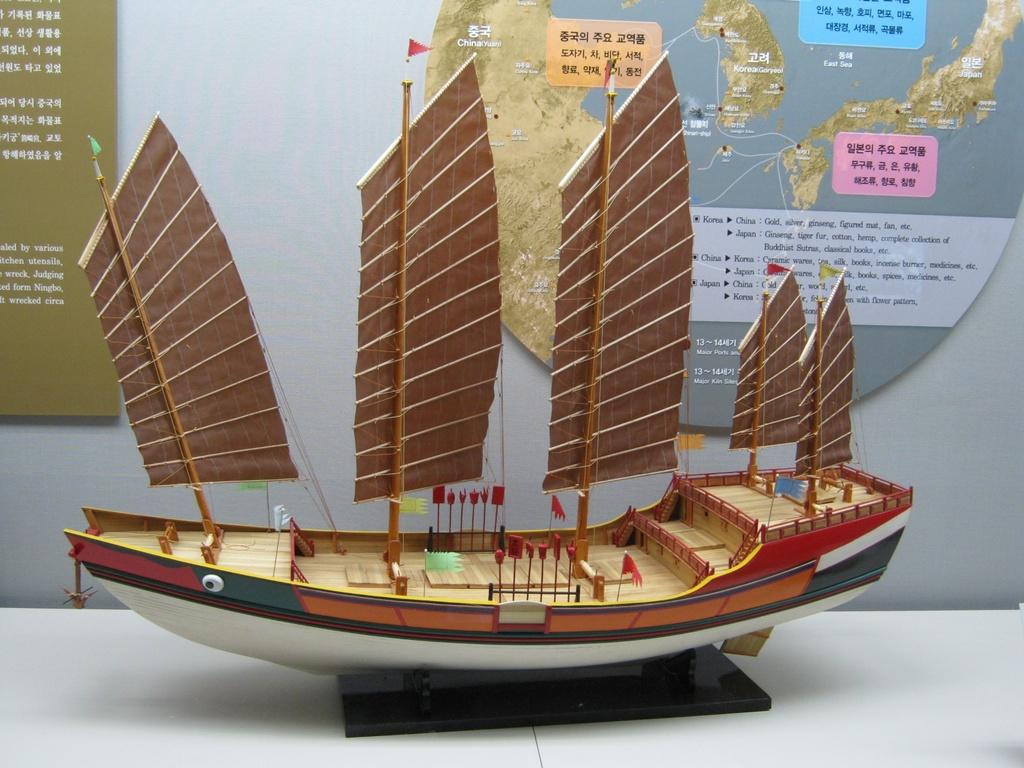What is the main object in the image? There is a toy boat in the image. What is the color of the surface the toy boat is on? The toy boat is on a white surface. What other object can be seen on the white surface? There is a black color object on the white surface. What can be seen in the background of the image? There is a wall in the background of the image. What is on the wall in the background? There are posters with text and images on the wall in the background. What type of crayon is being used to draw on the toy boat in the image? There is no crayon or drawing on the toy boat in the image. What is the annual income of the person who owns the toy boat in the image? There is no information about the owner of the toy boat or their income in the image. 